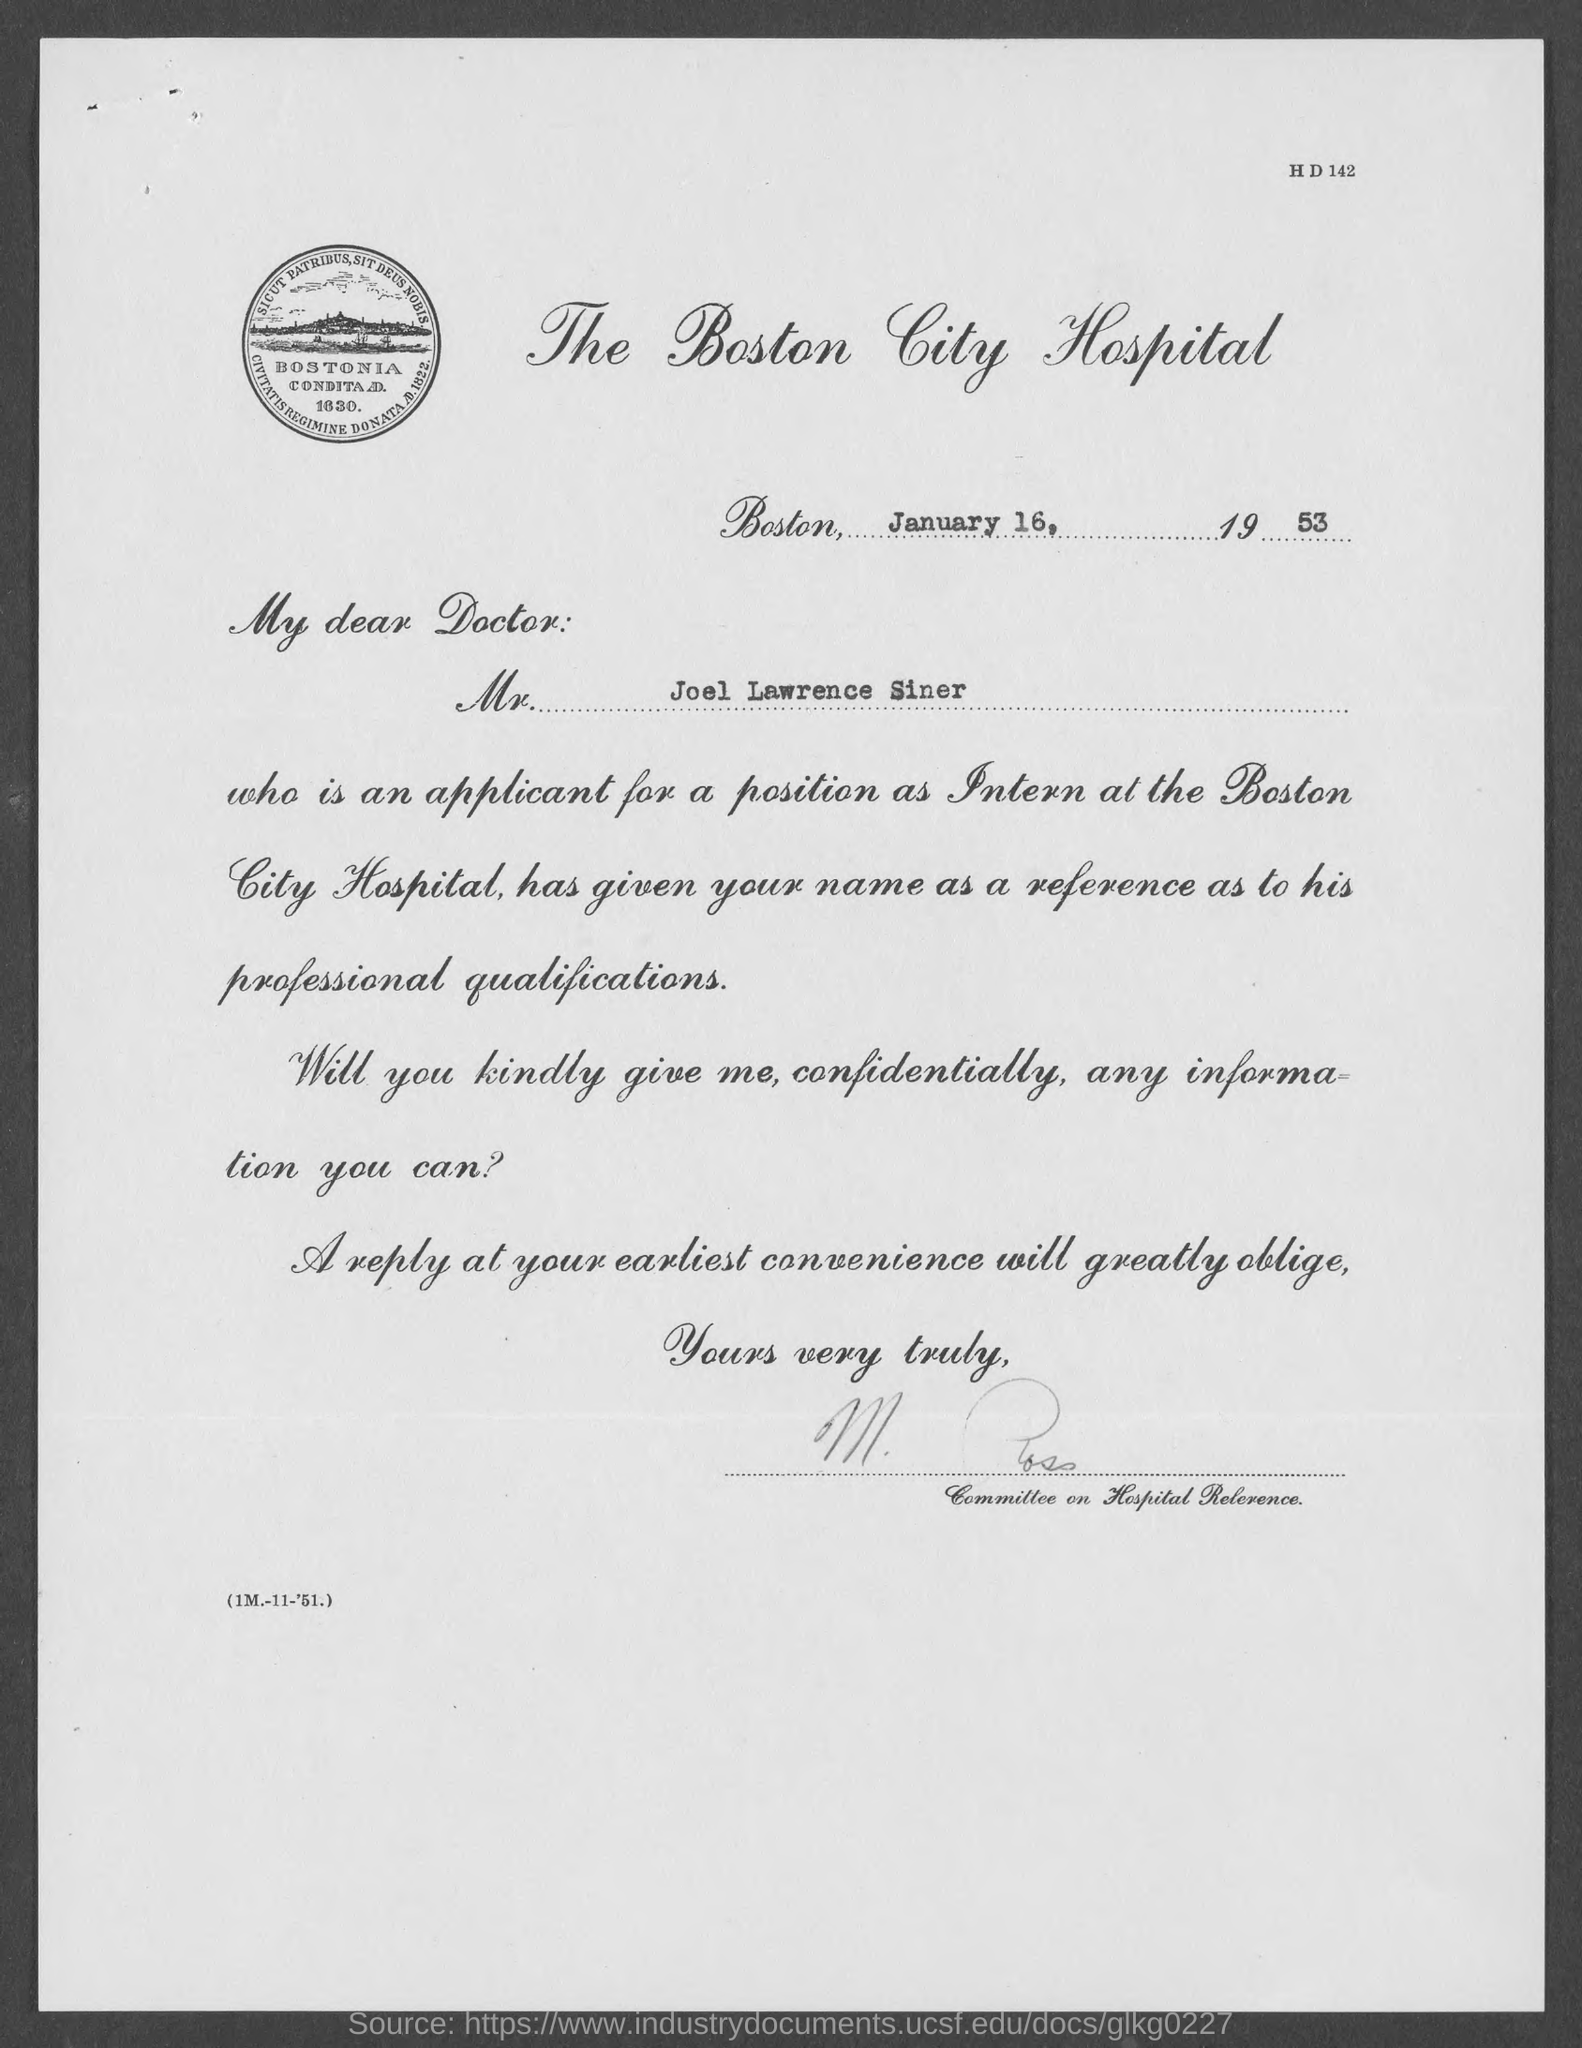Give some essential details in this illustration. On January 16, 1953, the letter was dated. The applicant applied for the position of intern. The letter is written from Boston. The applicant's name is Joel Lawrence Siner. 